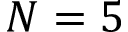Convert formula to latex. <formula><loc_0><loc_0><loc_500><loc_500>N = 5</formula> 